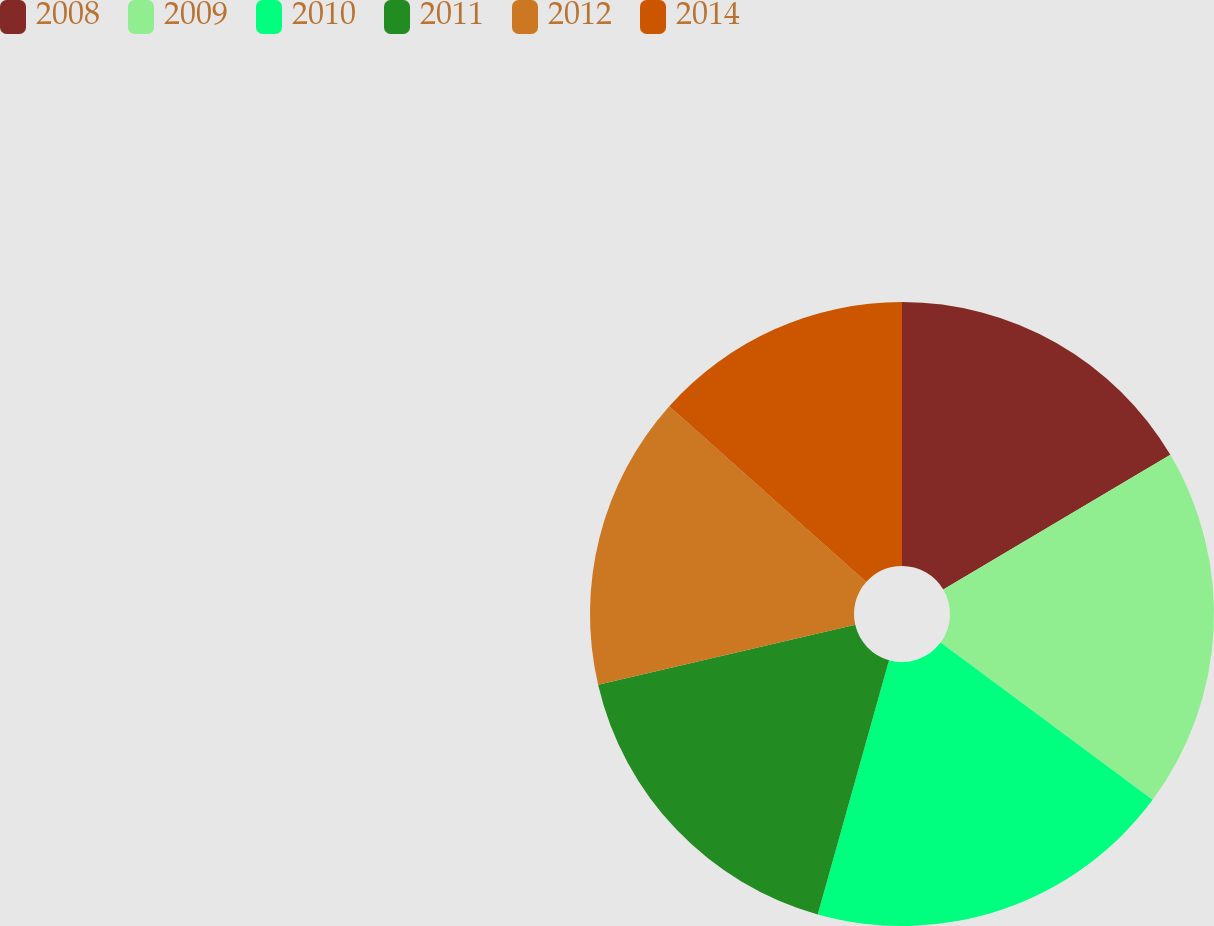Convert chart. <chart><loc_0><loc_0><loc_500><loc_500><pie_chart><fcel>2008<fcel>2009<fcel>2010<fcel>2011<fcel>2012<fcel>2014<nl><fcel>16.48%<fcel>18.68%<fcel>19.2%<fcel>17.01%<fcel>15.24%<fcel>13.4%<nl></chart> 